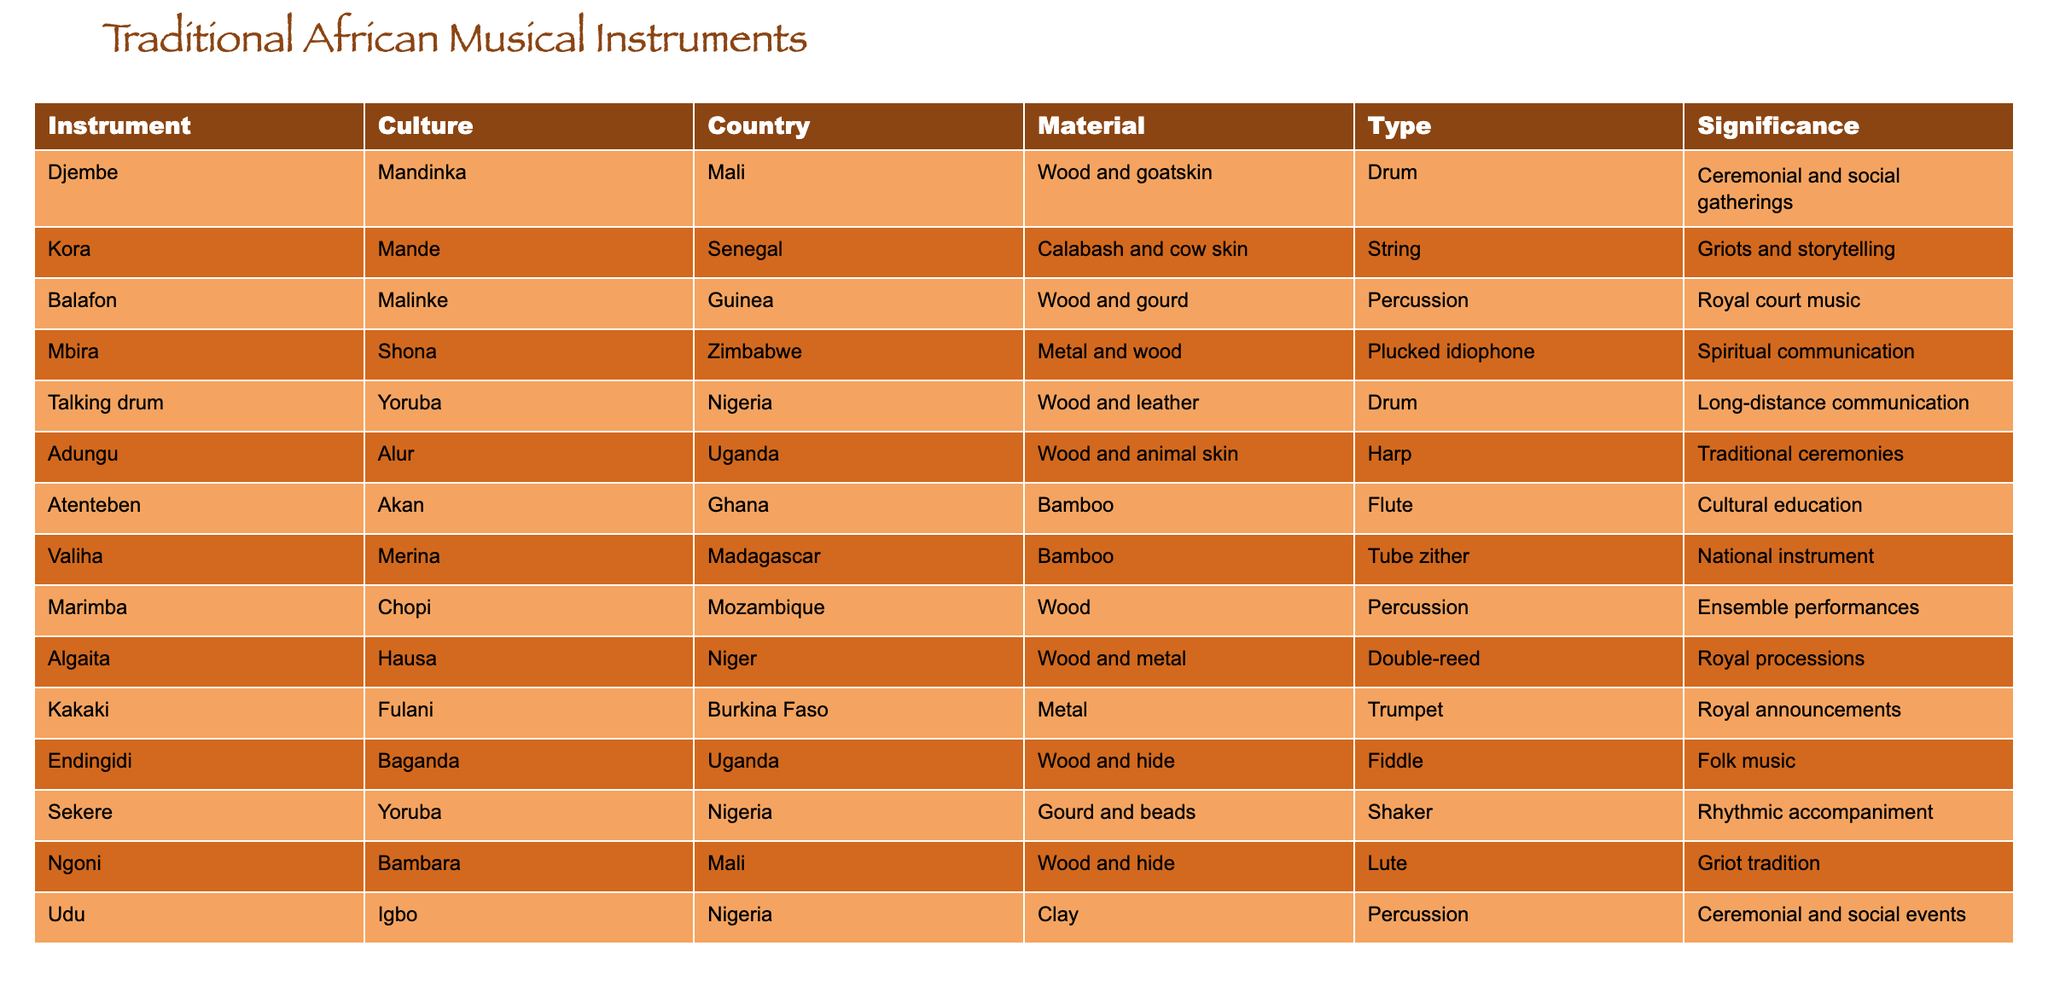What is the material used for the Djembe? The Djembe is made of wood and goatskin, which can be found in the 'Material' column corresponding to the instrument 'Djembe'.
Answer: Wood and goatskin Which instrument is significant for royal court music? The Balafon is noted for its significance in royal court music. This can be verified by looking at the 'Significance' column for the instrument listed as 'Balafon'.
Answer: Balafon True or False: The Kora is used primarily for ceremonial purposes. The Kora's significance is listed as "Griots and storytelling," indicating it is not primarily for ceremonial purposes. Thus, the statement is false.
Answer: False How many instruments in the table are made of wood? By counting the instruments listed under the 'Material' column, we find that the Djembe, Balafon, Adungu, Ngoni, Udu, and Endingidi are made of wood. This gives a total of 6 instruments made of wood.
Answer: 6 Which instrument is associated with long-distance communication? The Talking drum is associated with long-distance communication. This can be confirmed by checking the 'Significance' column for the corresponding instrument.
Answer: Talking drum What is the average number of materials used across all instruments? To find the average, we note that the materials for the instruments are: Wood and goatskin, Calabash and cow skin, Wood and gourd, Metal and wood, Wood and leather, Wood and animal skin, Bamboo, Bamboo, Wood, Wood and metal, Metal, Wood and hide, Gourd and beads, Wood and hide, and Clay. Counting distinct materials reveals nine distinct materials used. Since we have 14 instruments listed, the average is 9/14 = 0.64 distinct materials per instrument.
Answer: 0.64 Which country is associated with the Kakaki instrument? The Kakaki instrument is associated with Burkina Faso, which can be verified by looking at the 'Country' column next to the 'Kakaki' entry.
Answer: Burkina Faso Name an instrument used in spiritual communication and its material. The Mbira is used for spiritual communication and is made of metal and wood, which can be found by examining both the 'Significance' and 'Material' columns for the corresponding instrument.
Answer: Mbira, metal and wood 